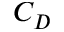<formula> <loc_0><loc_0><loc_500><loc_500>C _ { D }</formula> 